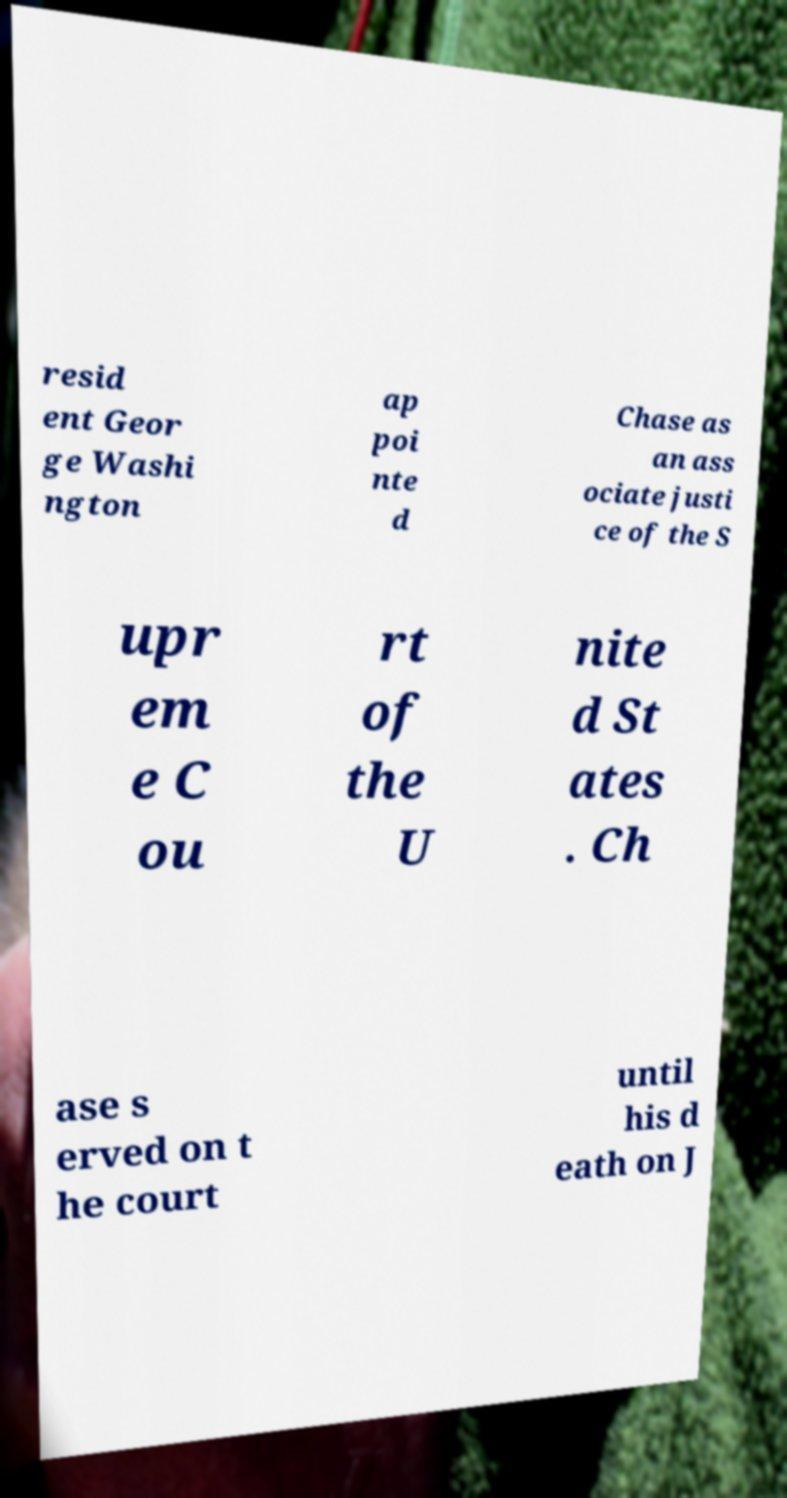What messages or text are displayed in this image? I need them in a readable, typed format. resid ent Geor ge Washi ngton ap poi nte d Chase as an ass ociate justi ce of the S upr em e C ou rt of the U nite d St ates . Ch ase s erved on t he court until his d eath on J 